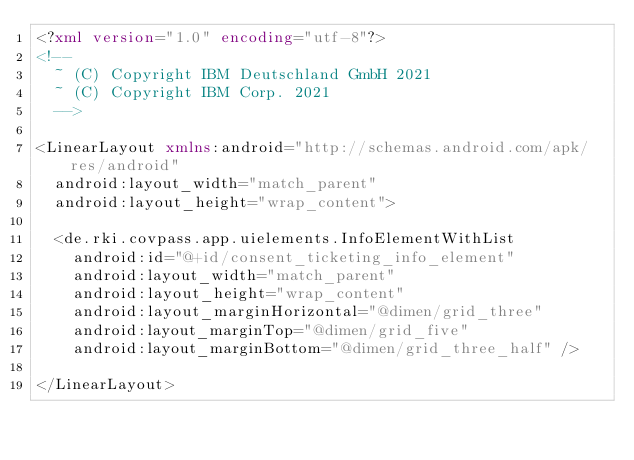Convert code to text. <code><loc_0><loc_0><loc_500><loc_500><_XML_><?xml version="1.0" encoding="utf-8"?>
<!--
  ~ (C) Copyright IBM Deutschland GmbH 2021
  ~ (C) Copyright IBM Corp. 2021
  -->

<LinearLayout xmlns:android="http://schemas.android.com/apk/res/android"
  android:layout_width="match_parent"
  android:layout_height="wrap_content">

  <de.rki.covpass.app.uielements.InfoElementWithList
    android:id="@+id/consent_ticketing_info_element"
    android:layout_width="match_parent"
    android:layout_height="wrap_content"
    android:layout_marginHorizontal="@dimen/grid_three"
    android:layout_marginTop="@dimen/grid_five"
    android:layout_marginBottom="@dimen/grid_three_half" />

</LinearLayout>
</code> 